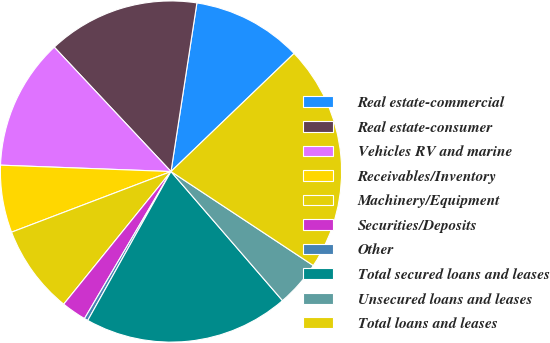Convert chart to OTSL. <chart><loc_0><loc_0><loc_500><loc_500><pie_chart><fcel>Real estate-commercial<fcel>Real estate-consumer<fcel>Vehicles RV and marine<fcel>Receivables/Inventory<fcel>Machinery/Equipment<fcel>Securities/Deposits<fcel>Other<fcel>Total secured loans and leases<fcel>Unsecured loans and leases<fcel>Total loans and leases<nl><fcel>10.4%<fcel>14.42%<fcel>12.41%<fcel>6.38%<fcel>8.39%<fcel>2.36%<fcel>0.35%<fcel>19.45%<fcel>4.37%<fcel>21.46%<nl></chart> 